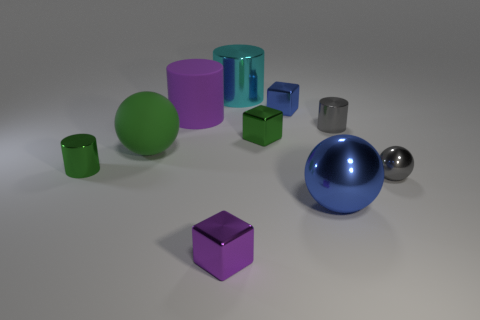There is a matte ball; does it have the same size as the blue object in front of the matte cylinder?
Your response must be concise. Yes. How many cylinders are either tiny purple objects or large cyan metal objects?
Give a very brief answer. 1. What number of tiny gray objects are on the left side of the tiny metal sphere and in front of the large rubber ball?
Your response must be concise. 0. What number of other objects are the same color as the matte cylinder?
Offer a very short reply. 1. What shape is the blue object behind the large metal sphere?
Provide a short and direct response. Cube. Are the tiny purple object and the purple cylinder made of the same material?
Provide a short and direct response. No. What number of small cylinders are behind the cyan cylinder?
Ensure brevity in your answer.  0. What is the shape of the large metallic thing that is behind the small metal thing that is behind the purple cylinder?
Give a very brief answer. Cylinder. Is the number of things that are in front of the tiny blue cube greater than the number of metallic things?
Provide a short and direct response. No. There is a blue ball that is to the right of the purple cylinder; what number of blocks are behind it?
Your answer should be very brief. 2. 